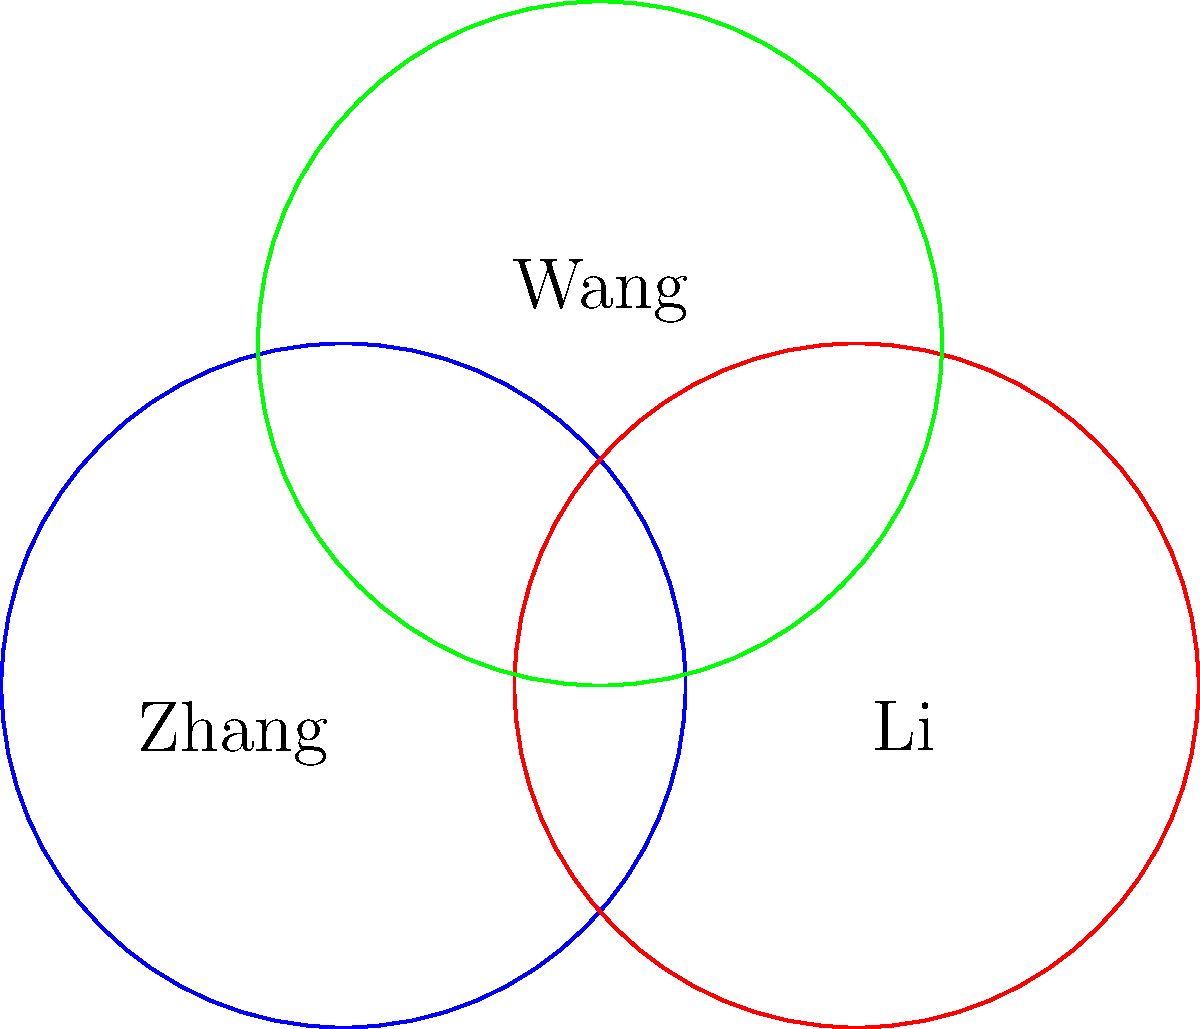Three circles represent the regional distribution of Chinese surnames Zhang, Li, and Wang. Each circle has a radius of 2 units, with centers at (0,0), (3,0), and (1.5,2) respectively. How many points of intersection are there for all three circles, and what are the coordinates of point A, which is the uppermost intersection point? To solve this problem, we need to follow these steps:

1) First, we need to find the number of intersection points for all three circles. From the diagram, we can see that there are two points where all three circles intersect.

2) To find the coordinates of point A (the uppermost intersection point), we need to solve the system of equations for the three circles:

   Circle 1 (Zhang): $$(x-0)^2 + (y-0)^2 = 2^2$$
   Circle 2 (Li): $$(x-3)^2 + (y-0)^2 = 2^2$$
   Circle 3 (Wang): $$(x-1.5)^2 + (y-2)^2 = 2^2$$

3) Solving this system of equations is complex, but we can use the symmetry of the diagram to simplify our work. We can see that point A is on the perpendicular bisector of the line connecting the centers of the Zhang and Li circles.

4) The equation of this perpendicular bisector is $x = 1.5$.

5) Substituting this into the equation of the Wang circle:

   $$(1.5-1.5)^2 + (y-2)^2 = 2^2$$
   $$y^2 - 4y + 4 = 4$$
   $$y^2 - 4y = 0$$
   $$y(y-4) = 0$$

6) Solving this, we get $y = 0$ or $y = 4$. Since A is the uppermost point, $y = 4$.

Therefore, the coordinates of point A are (1.5, 4).
Answer: 2 intersection points; A(1.5, 4) 